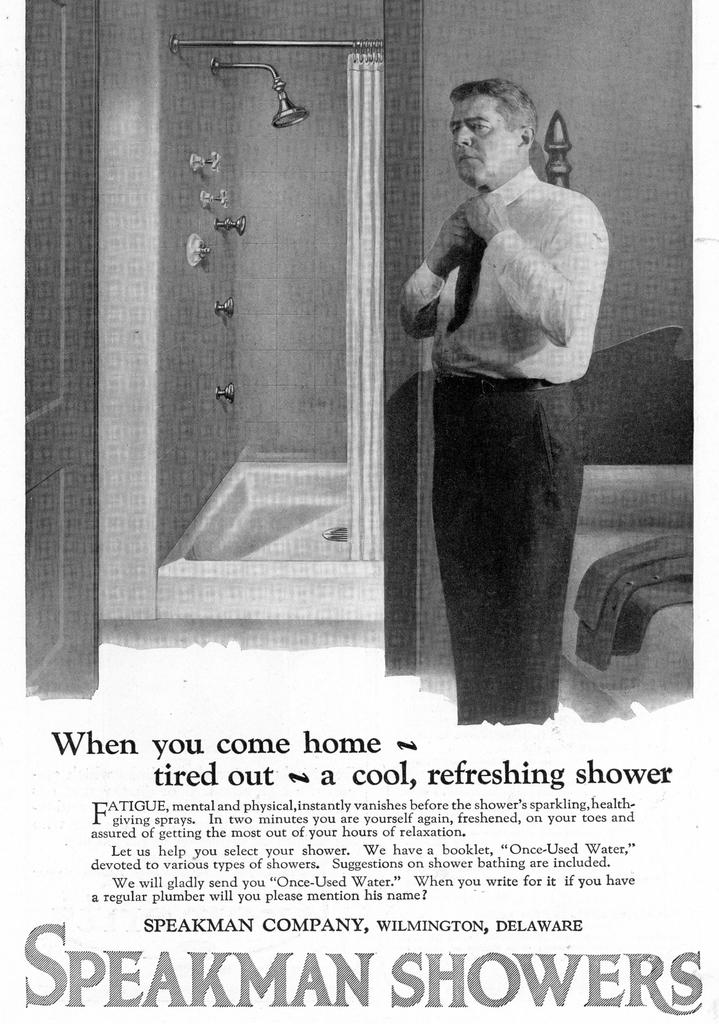<image>
Write a terse but informative summary of the picture. A black and white advertisement for Speakman Showers 